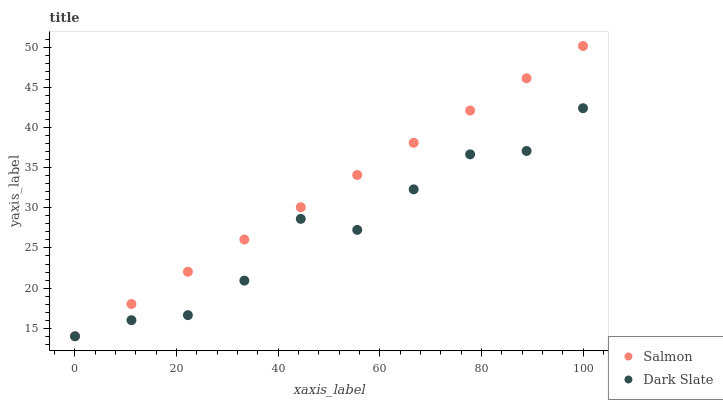Does Dark Slate have the minimum area under the curve?
Answer yes or no. Yes. Does Salmon have the maximum area under the curve?
Answer yes or no. Yes. Does Salmon have the minimum area under the curve?
Answer yes or no. No. Is Salmon the smoothest?
Answer yes or no. Yes. Is Dark Slate the roughest?
Answer yes or no. Yes. Is Salmon the roughest?
Answer yes or no. No. Does Dark Slate have the lowest value?
Answer yes or no. Yes. Does Salmon have the highest value?
Answer yes or no. Yes. Does Salmon intersect Dark Slate?
Answer yes or no. Yes. Is Salmon less than Dark Slate?
Answer yes or no. No. Is Salmon greater than Dark Slate?
Answer yes or no. No. 